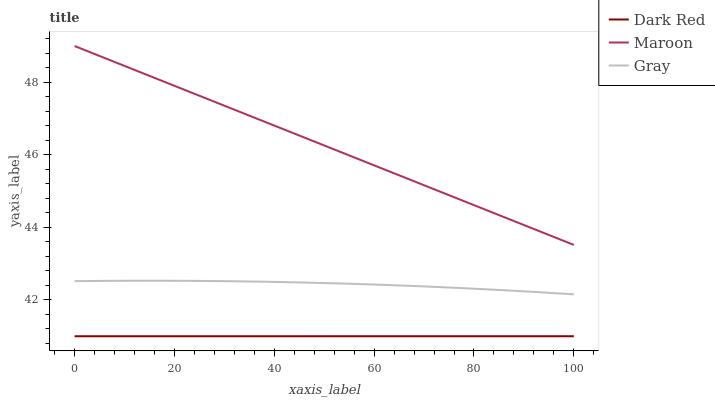Does Dark Red have the minimum area under the curve?
Answer yes or no. Yes. Does Maroon have the maximum area under the curve?
Answer yes or no. Yes. Does Gray have the minimum area under the curve?
Answer yes or no. No. Does Gray have the maximum area under the curve?
Answer yes or no. No. Is Maroon the smoothest?
Answer yes or no. Yes. Is Gray the roughest?
Answer yes or no. Yes. Is Gray the smoothest?
Answer yes or no. No. Is Maroon the roughest?
Answer yes or no. No. Does Dark Red have the lowest value?
Answer yes or no. Yes. Does Gray have the lowest value?
Answer yes or no. No. Does Maroon have the highest value?
Answer yes or no. Yes. Does Gray have the highest value?
Answer yes or no. No. Is Dark Red less than Maroon?
Answer yes or no. Yes. Is Gray greater than Dark Red?
Answer yes or no. Yes. Does Dark Red intersect Maroon?
Answer yes or no. No. 